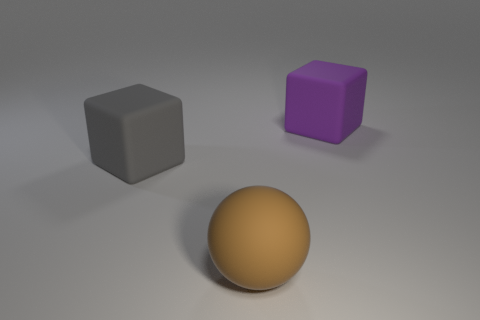Does the big rubber object that is in front of the large gray rubber block have the same color as the rubber cube that is to the left of the big purple matte thing?
Give a very brief answer. No. There is another thing that is the same shape as the large gray rubber thing; what size is it?
Keep it short and to the point. Large. Is there a large cube of the same color as the large rubber ball?
Keep it short and to the point. No. How many cubes have the same color as the big rubber ball?
Provide a succinct answer. 0. How many things are either rubber blocks that are right of the gray block or balls?
Keep it short and to the point. 2. What color is the large ball that is the same material as the big gray cube?
Offer a terse response. Brown. Are there any gray matte things of the same size as the gray matte cube?
Keep it short and to the point. No. How many things are either gray rubber objects on the left side of the big purple matte thing or rubber things that are right of the large matte sphere?
Offer a very short reply. 2. There is a brown object that is the same size as the gray cube; what is its shape?
Offer a very short reply. Sphere. Are there any big purple shiny objects of the same shape as the gray matte thing?
Ensure brevity in your answer.  No. 